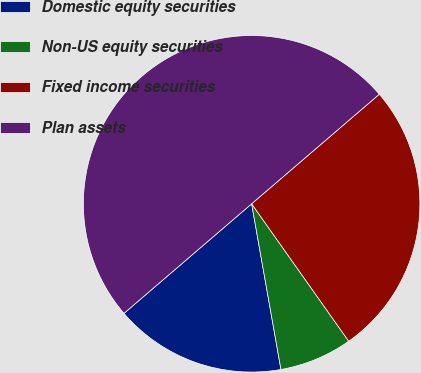Convert chart to OTSL. <chart><loc_0><loc_0><loc_500><loc_500><pie_chart><fcel>Domestic equity securities<fcel>Non-US equity securities<fcel>Fixed income securities<fcel>Plan assets<nl><fcel>16.5%<fcel>7.0%<fcel>26.5%<fcel>50.0%<nl></chart> 